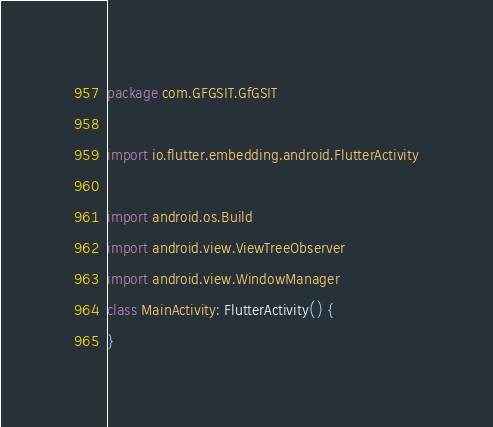<code> <loc_0><loc_0><loc_500><loc_500><_Kotlin_>package com.GFGSIT.GfGSIT

import io.flutter.embedding.android.FlutterActivity

import android.os.Build
import android.view.ViewTreeObserver
import android.view.WindowManager
class MainActivity: FlutterActivity() {
}
</code> 